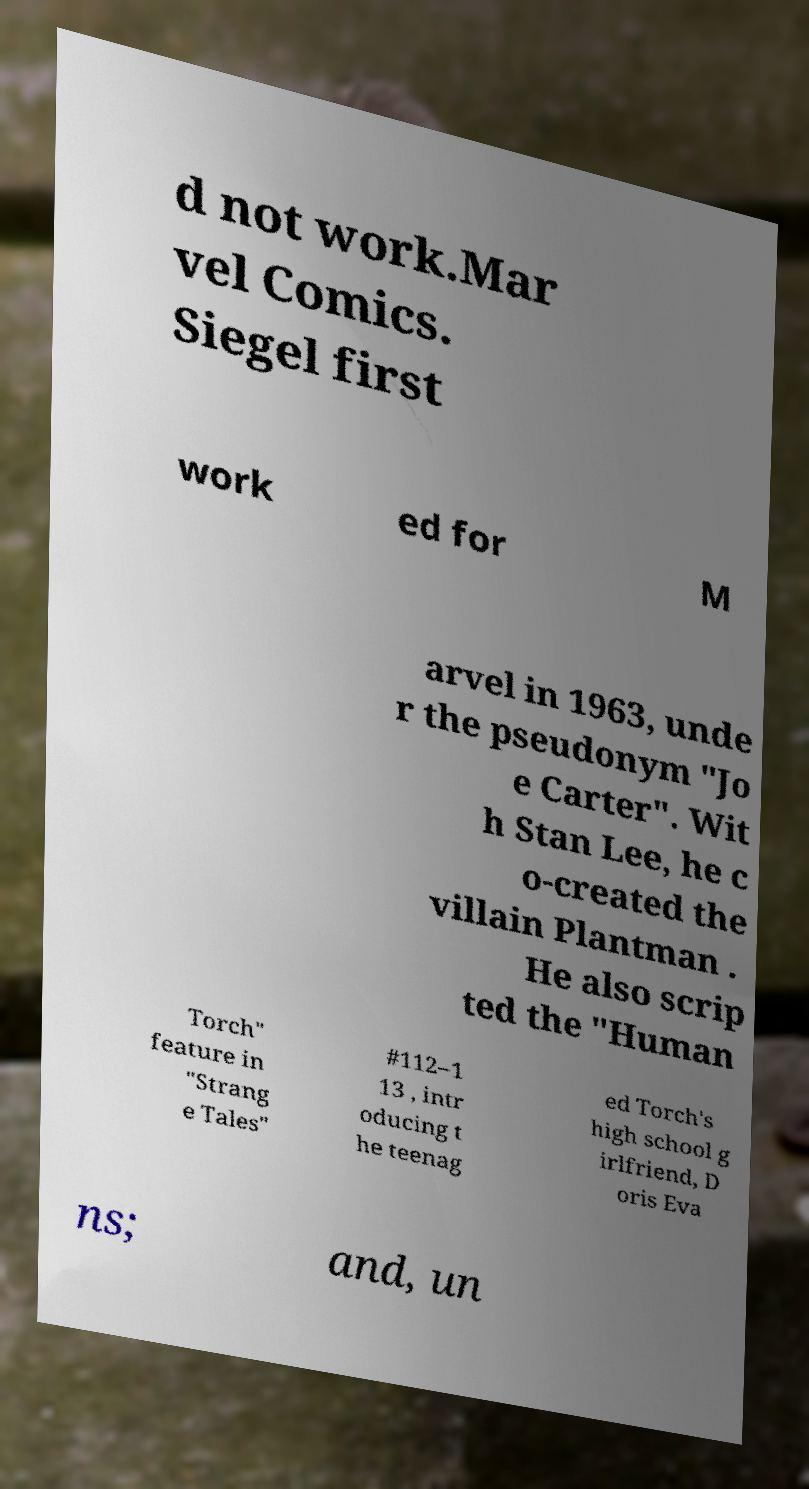Please identify and transcribe the text found in this image. d not work.Mar vel Comics. Siegel first work ed for M arvel in 1963, unde r the pseudonym "Jo e Carter". Wit h Stan Lee, he c o-created the villain Plantman . He also scrip ted the "Human Torch" feature in "Strang e Tales" #112–1 13 , intr oducing t he teenag ed Torch's high school g irlfriend, D oris Eva ns; and, un 